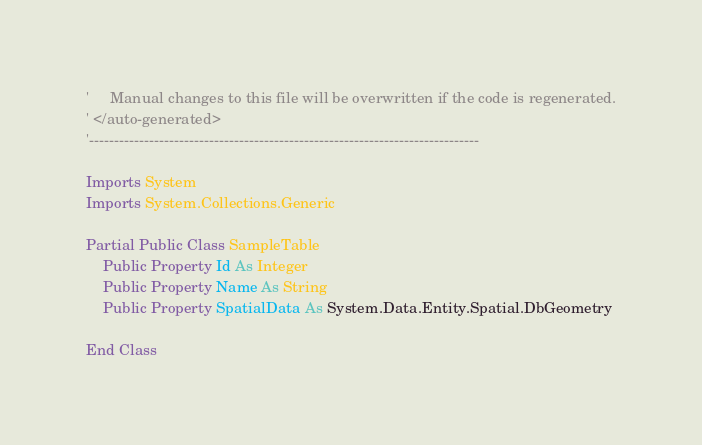Convert code to text. <code><loc_0><loc_0><loc_500><loc_500><_VisualBasic_>'     Manual changes to this file will be overwritten if the code is regenerated.
' </auto-generated>
'------------------------------------------------------------------------------

Imports System
Imports System.Collections.Generic

Partial Public Class SampleTable
    Public Property Id As Integer
    Public Property Name As String
    Public Property SpatialData As System.Data.Entity.Spatial.DbGeometry

End Class
</code> 